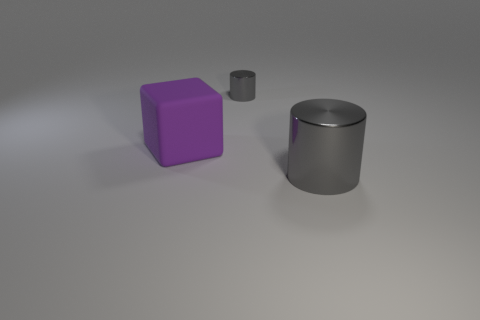Subtract 1 cubes. How many cubes are left? 0 Add 1 big purple metallic objects. How many objects exist? 4 Subtract all cylinders. How many objects are left? 1 Subtract all tiny gray shiny cylinders. Subtract all large gray metal things. How many objects are left? 1 Add 3 purple matte blocks. How many purple matte blocks are left? 4 Add 2 large metal cylinders. How many large metal cylinders exist? 3 Subtract 0 brown cylinders. How many objects are left? 3 Subtract all gray cubes. Subtract all blue cylinders. How many cubes are left? 1 